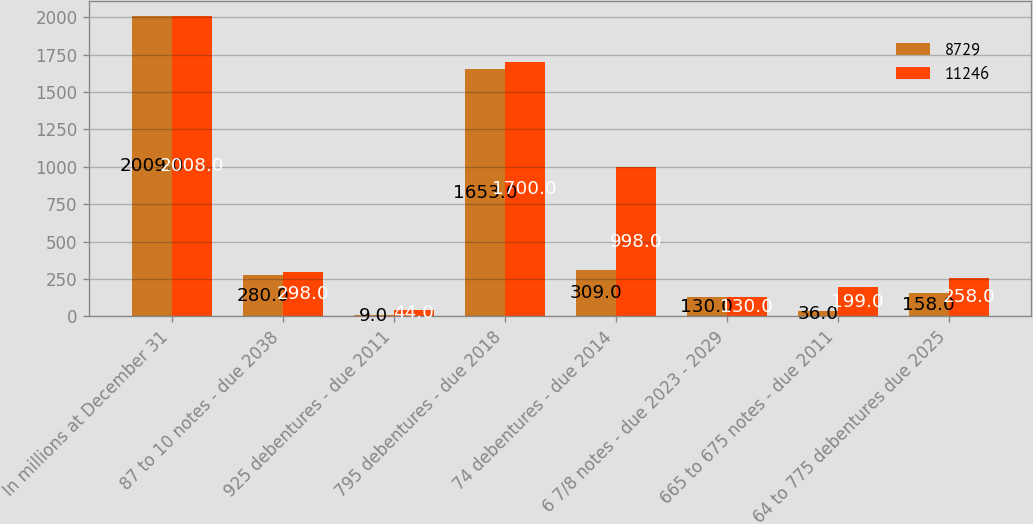Convert chart to OTSL. <chart><loc_0><loc_0><loc_500><loc_500><stacked_bar_chart><ecel><fcel>In millions at December 31<fcel>87 to 10 notes - due 2038<fcel>925 debentures - due 2011<fcel>795 debentures - due 2018<fcel>74 debentures - due 2014<fcel>6 7/8 notes - due 2023 - 2029<fcel>665 to 675 notes - due 2011<fcel>64 to 775 debentures due 2025<nl><fcel>8729<fcel>2009<fcel>280<fcel>9<fcel>1653<fcel>309<fcel>130<fcel>36<fcel>158<nl><fcel>11246<fcel>2008<fcel>298<fcel>44<fcel>1700<fcel>998<fcel>130<fcel>199<fcel>258<nl></chart> 